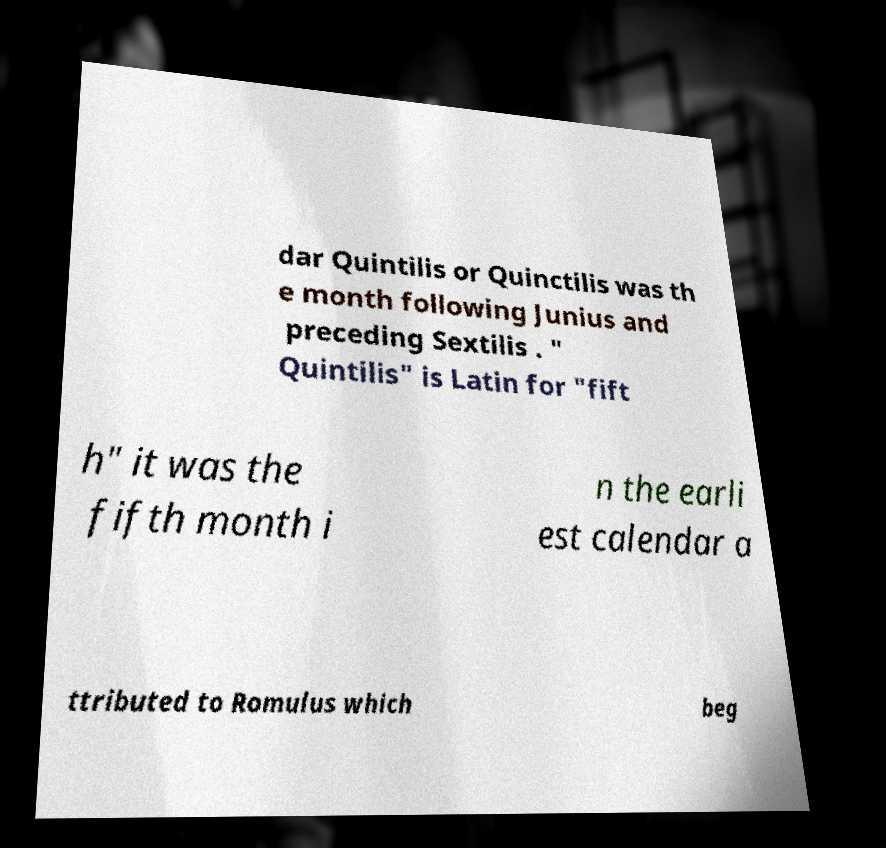Can you read and provide the text displayed in the image?This photo seems to have some interesting text. Can you extract and type it out for me? dar Quintilis or Quinctilis was th e month following Junius and preceding Sextilis . " Quintilis" is Latin for "fift h" it was the fifth month i n the earli est calendar a ttributed to Romulus which beg 